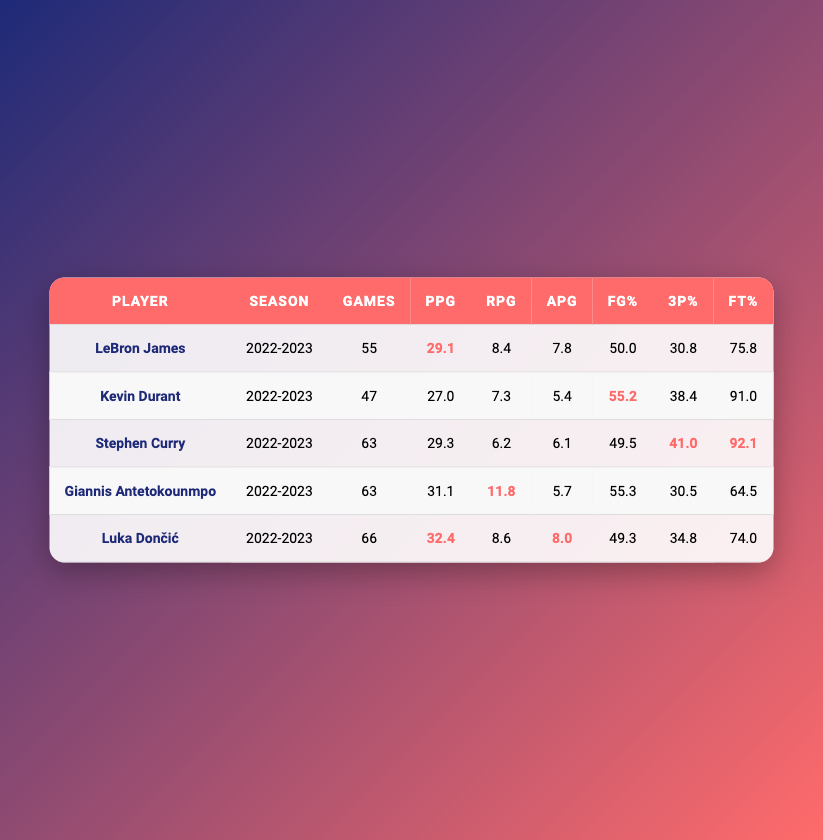What is Luka Dončić's points per game? In the table, Luka Dončić's points per game is listed in the "PPG" column for the 2022-2023 season. The value is 32.4.
Answer: 32.4 Who had the highest rebounds per game? By comparing the "RPG" values across players, Giannis Antetokounmpo has the highest rebounds at 11.8, which is more than any other player's rebounds per game listed.
Answer: Yes What is the average free throw percentage of the players listed? To find the average, sum the free throw percentages: (75.8 + 91.0 + 92.1 + 64.5 + 74.0) = 397.4. There are 5 players, so the average is 397.4/5 = 79.48.
Answer: 79.48 Did Stephen Curry play more games than Kevin Durant? Looking at the "Games" column, Stephen Curry played 63 games while Kevin Durant played 47. Since 63 is greater than 47, the statement is true.
Answer: Yes What is the difference in points per game between Luka Dončić and LeBron James? Luka Dončić scored 32.4 points per game, while LeBron James scored 29.1. The difference is 32.4 - 29.1 = 3.3.
Answer: 3.3 Which player had the highest field goal percentage? By evaluating the "FG%" column, Kevin Durant has the highest field goal percentage at 55.2, which is greater than the percentages of the other players listed.
Answer: Kevin Durant What is the total number of games played by all players? To find the total games played, add the games played: (55 + 47 + 63 + 63 + 66) = 294.
Answer: 294 Is it true that all players had a three-point percentage below 35%? Checking the “3P%” column, Stephen Curry has a three-point percentage of 41.0, which is above 35%. Thus, the statement is false.
Answer: No What percentage of games did LeBron James play compared to Luka Dončić? LeBron James played 55 games and Luka Dončić played 66 games. The percentage of games played by LeBron compared to Luka is (55/66)*100 = 83.33%.
Answer: 83.33% 